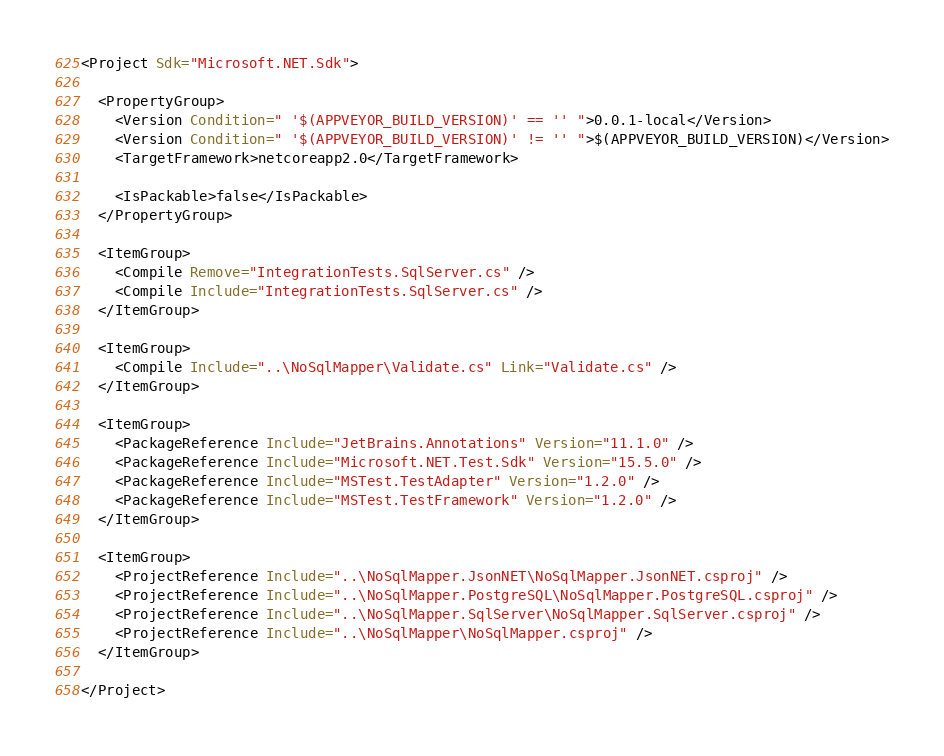<code> <loc_0><loc_0><loc_500><loc_500><_XML_><Project Sdk="Microsoft.NET.Sdk">

  <PropertyGroup>
    <Version Condition=" '$(APPVEYOR_BUILD_VERSION)' == '' ">0.0.1-local</Version>
    <Version Condition=" '$(APPVEYOR_BUILD_VERSION)' != '' ">$(APPVEYOR_BUILD_VERSION)</Version>
    <TargetFramework>netcoreapp2.0</TargetFramework>

    <IsPackable>false</IsPackable>
  </PropertyGroup>

  <ItemGroup>
    <Compile Remove="IntegrationTests.SqlServer.cs" />
    <Compile Include="IntegrationTests.SqlServer.cs" />
  </ItemGroup>

  <ItemGroup>
    <Compile Include="..\NoSqlMapper\Validate.cs" Link="Validate.cs" />
  </ItemGroup>

  <ItemGroup>
    <PackageReference Include="JetBrains.Annotations" Version="11.1.0" />
    <PackageReference Include="Microsoft.NET.Test.Sdk" Version="15.5.0" />
    <PackageReference Include="MSTest.TestAdapter" Version="1.2.0" />
    <PackageReference Include="MSTest.TestFramework" Version="1.2.0" />
  </ItemGroup>

  <ItemGroup>
    <ProjectReference Include="..\NoSqlMapper.JsonNET\NoSqlMapper.JsonNET.csproj" />
    <ProjectReference Include="..\NoSqlMapper.PostgreSQL\NoSqlMapper.PostgreSQL.csproj" />
    <ProjectReference Include="..\NoSqlMapper.SqlServer\NoSqlMapper.SqlServer.csproj" />
    <ProjectReference Include="..\NoSqlMapper\NoSqlMapper.csproj" />
  </ItemGroup>

</Project>
</code> 